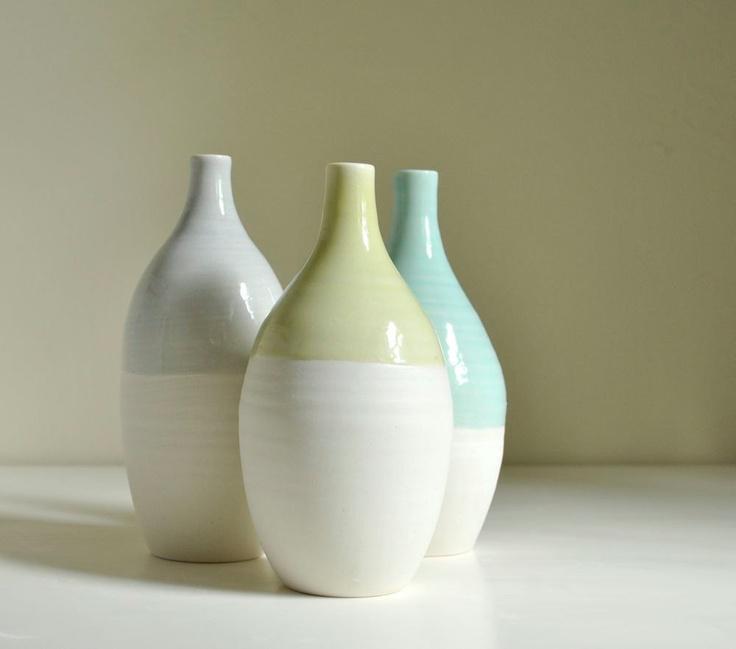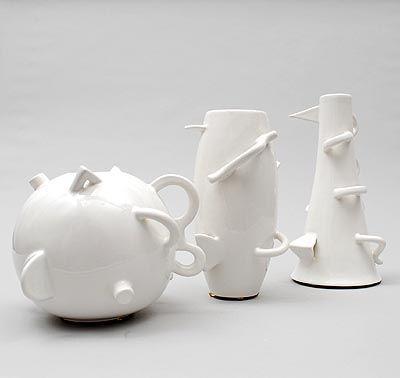The first image is the image on the left, the second image is the image on the right. For the images shown, is this caption "There are at most six vases." true? Answer yes or no. Yes. The first image is the image on the left, the second image is the image on the right. Analyze the images presented: Is the assertion "There is no more than three sculptures in the left image." valid? Answer yes or no. Yes. 